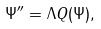<formula> <loc_0><loc_0><loc_500><loc_500>\Psi ^ { \prime \prime } = \Lambda Q ( \Psi ) ,</formula> 